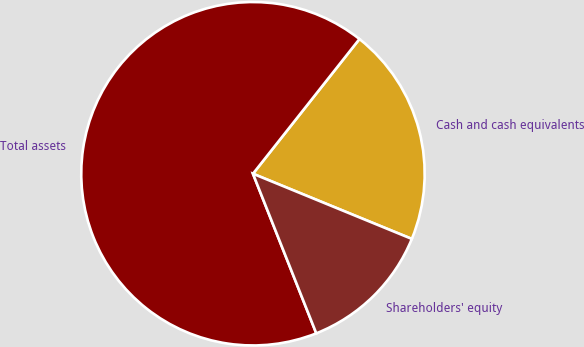Convert chart to OTSL. <chart><loc_0><loc_0><loc_500><loc_500><pie_chart><fcel>Cash and cash equivalents<fcel>Total assets<fcel>Shareholders' equity<nl><fcel>20.55%<fcel>66.65%<fcel>12.79%<nl></chart> 